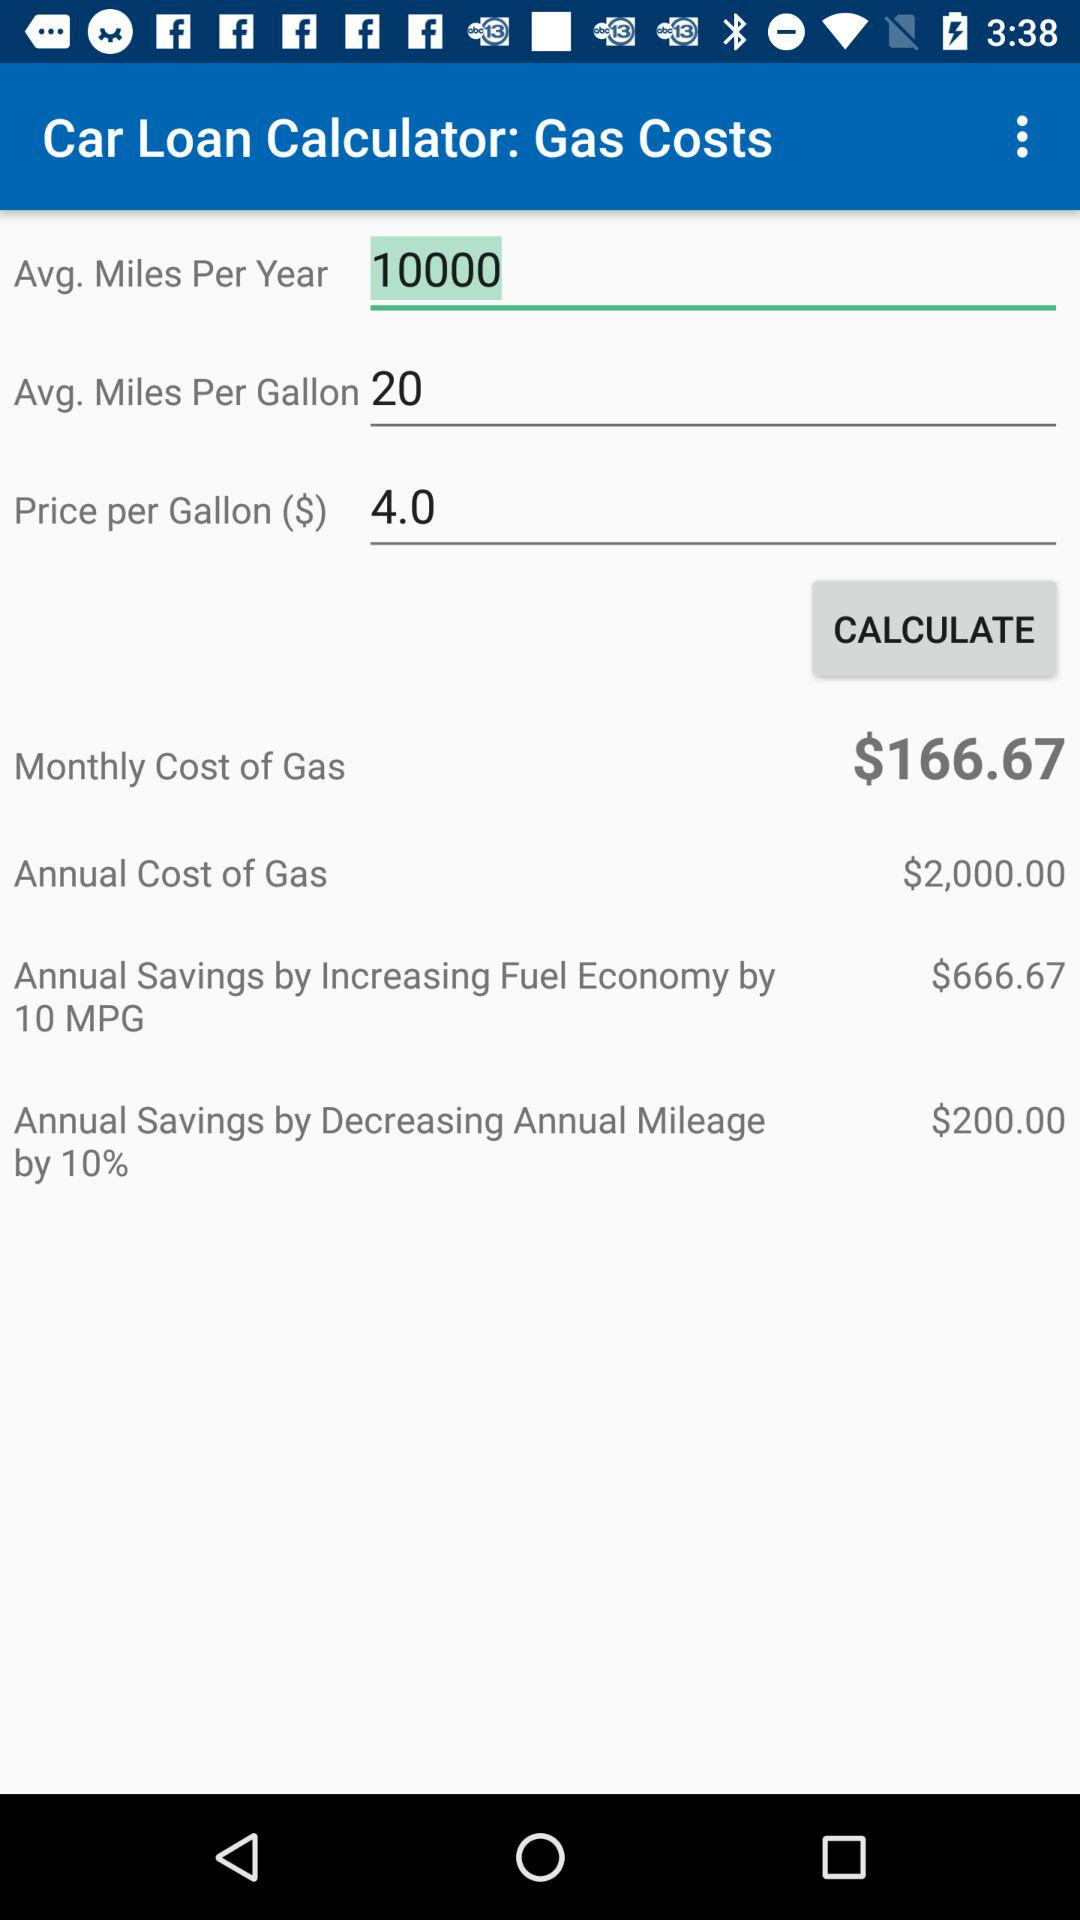What is the price per gallon? The price per gallon is $4. 